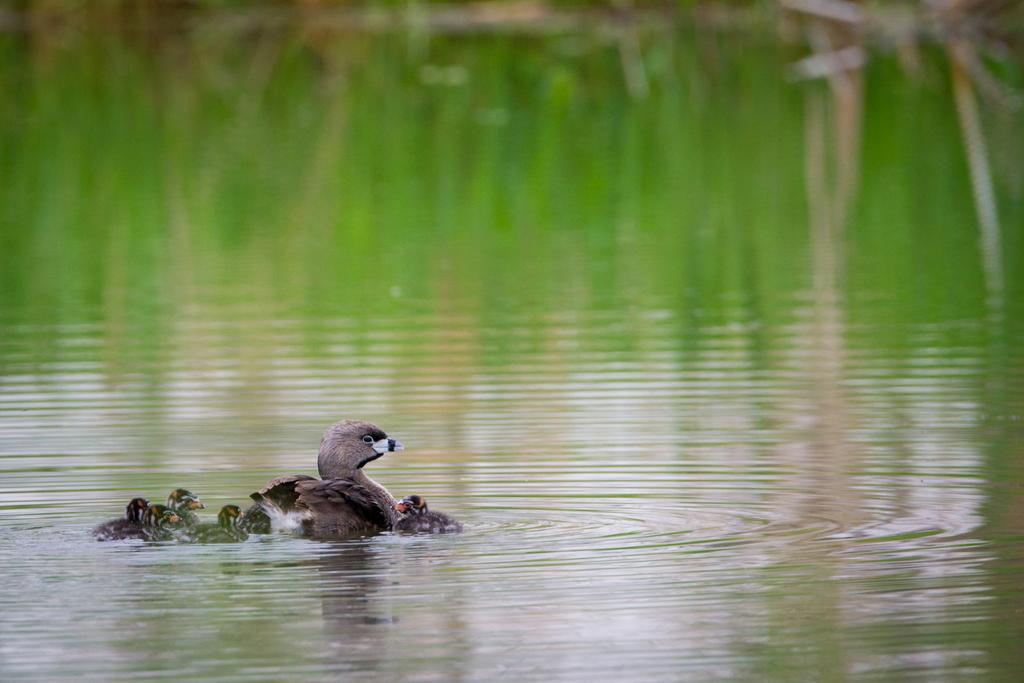Please provide a concise description of this image. In this image, we can see birds on the water. 